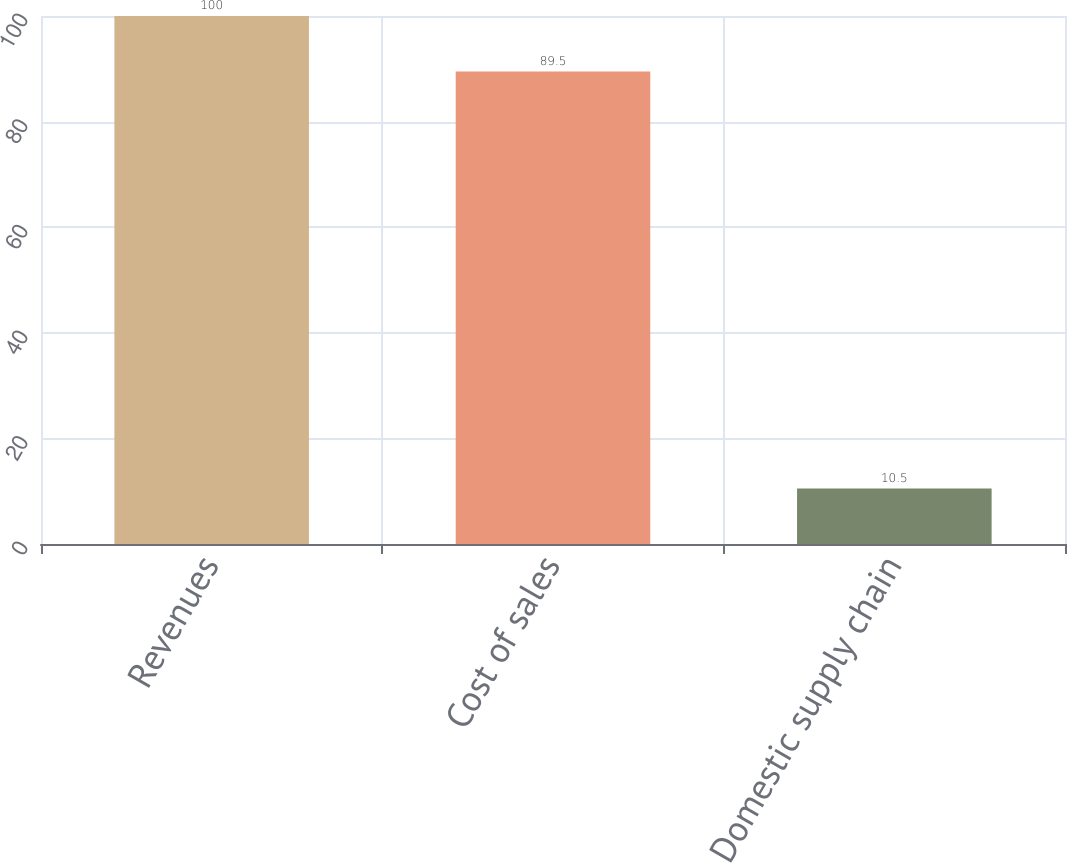Convert chart. <chart><loc_0><loc_0><loc_500><loc_500><bar_chart><fcel>Revenues<fcel>Cost of sales<fcel>Domestic supply chain<nl><fcel>100<fcel>89.5<fcel>10.5<nl></chart> 